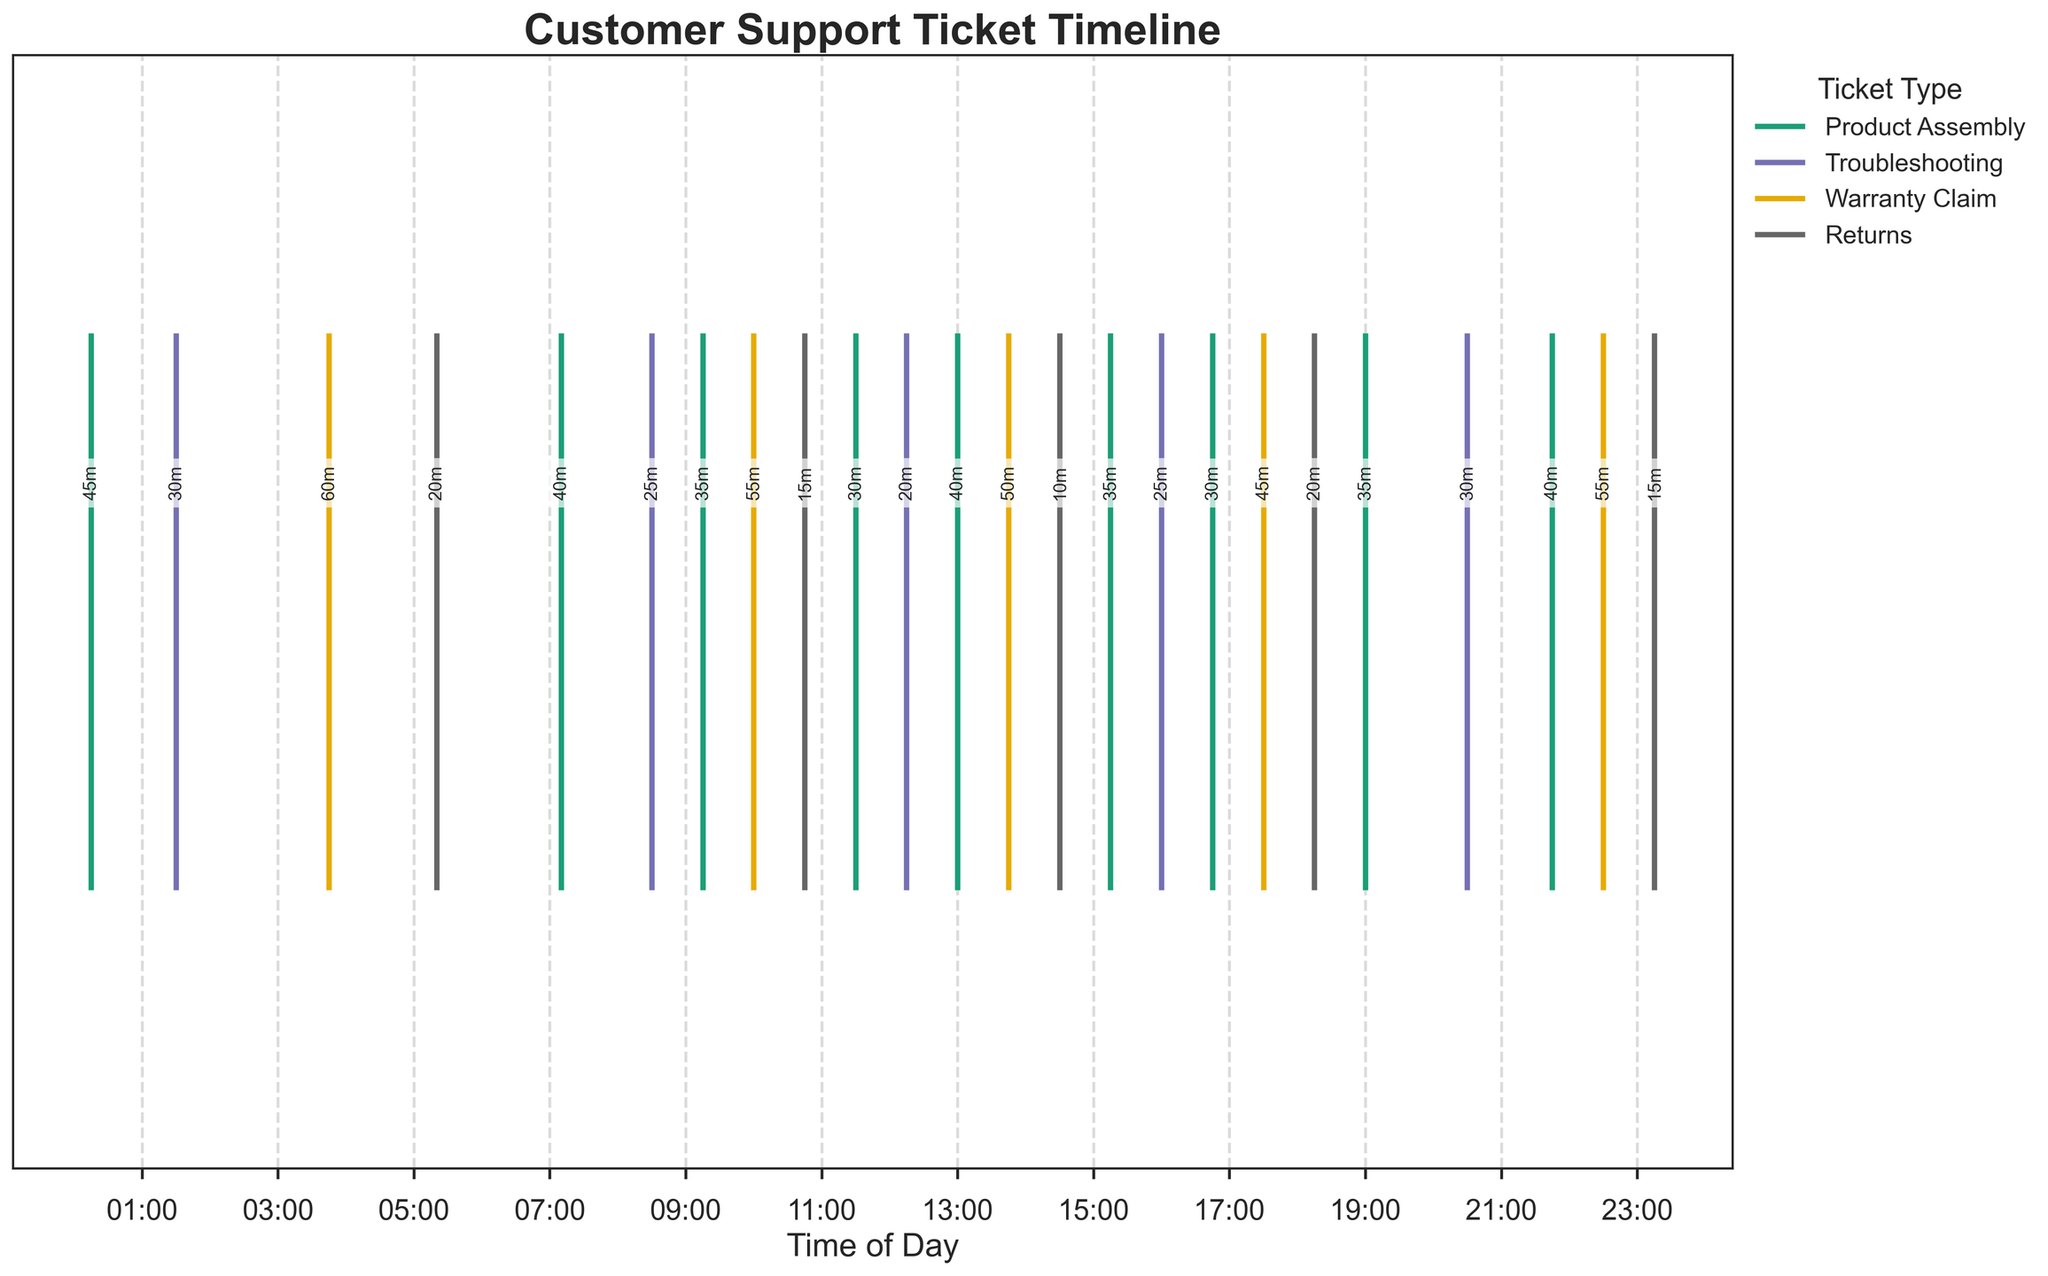What's the title of the figure? The title of the figure is displayed prominently at the top. It reads "Customer Support Ticket Timeline," reflecting the content and focus of the plot.
Answer: Customer Support Ticket Timeline How many types of customer support tickets are shown in the legend? The legend is located at the upper left of the figure, and it lists the different types of tickets. There are four types: Product Assembly, Troubleshooting, Warranty Claim, and Returns.
Answer: 4 What are the busiest hours for Product Assembly tickets? The Product Assembly tickets are indicated by their specific color along the x-axis. The timestamps with the highest concentration of these tickets are between 07:00 and 11:30 and again between 15:00 and 21:45.
Answer: 07:00-11:30, 15:00-21:45 Which ticket type has the shortest response time, and what is it? By reading the text annotations above each event line, you can compare the response times. The Returns type has a response time of 10 minutes, which is the shortest.
Answer: Returns, 10 minutes How many Product Assembly tickets were processed in total? Count the lines or entries corresponding to Product Assembly in the plot or legend. There are six entries in total.
Answer: 6 What time did the ticket with the longest response time occur, and what was the time? By visually comparing the numerical annotations for response times, the longest response time can be identified. The Warranty Claim ticket at 22:30 had the longest response time of 55 minutes.
Answer: 22:30, 55 minutes What's the average response time for Troubleshooting tickets? Sum the response times for all Troubleshooting tickets (30+25+20+25+30 = 130). There are 5 Troubleshooting tickets, so the average response time is 130/5 = 26 minutes.
Answer: 26 minutes Compare the response times for tickets at 03:45 and 17:30. Which one was faster? Identify the response times from the text above the timestamps. The response time at 03:45 (Warranty Claim) is 60 minutes, and at 17:30 (Warranty Claim) is 45 minutes. Hence, 17:30 is faster.
Answer: 17:30 Which category showed more frequent processing around 09:00 - 11:00? Check the timestamps and event lines around the given time window, focusing on the number of events. Product Assembly tickets (09:15 and 10:00) are more frequent than Troubleshooting (08:30) and Returns (10:45).
Answer: Product Assembly What is the median response time for Warranty Claim tickets? List the response times for Warranty Claim tickets: (60, 55, 50, 55, 45), then find the middle value. The median is the third value in this sorted list.
Answer: 55 